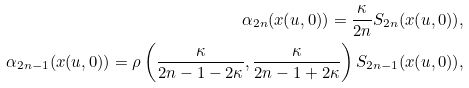<formula> <loc_0><loc_0><loc_500><loc_500>\alpha _ { 2 n } ( x ( u , 0 ) ) = \frac { \kappa } { 2 n } S _ { 2 n } ( x ( u , 0 ) ) , \\ \alpha _ { 2 n - 1 } ( x ( u , 0 ) ) = \rho \left ( \frac { \kappa } { 2 n - 1 - 2 \kappa } , \frac { \kappa } { 2 n - 1 + 2 \kappa } \right ) S _ { 2 n - 1 } ( x ( u , 0 ) ) ,</formula> 